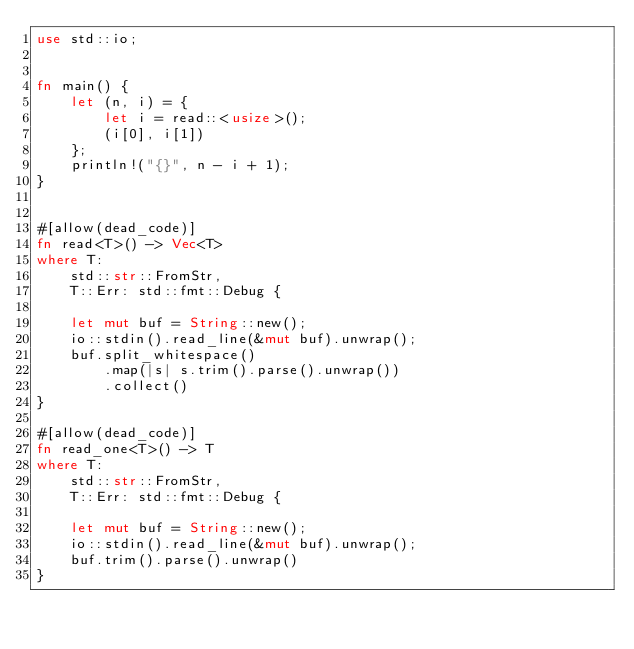Convert code to text. <code><loc_0><loc_0><loc_500><loc_500><_Rust_>use std::io;


fn main() {
    let (n, i) = {
        let i = read::<usize>();
        (i[0], i[1])
    };
    println!("{}", n - i + 1);
}


#[allow(dead_code)]
fn read<T>() -> Vec<T>
where T:
    std::str::FromStr,
    T::Err: std::fmt::Debug {

    let mut buf = String::new();
    io::stdin().read_line(&mut buf).unwrap();
    buf.split_whitespace()
        .map(|s| s.trim().parse().unwrap())
        .collect()
}

#[allow(dead_code)]
fn read_one<T>() -> T
where T:
    std::str::FromStr,
    T::Err: std::fmt::Debug {

    let mut buf = String::new();
    io::stdin().read_line(&mut buf).unwrap();
    buf.trim().parse().unwrap()
}</code> 